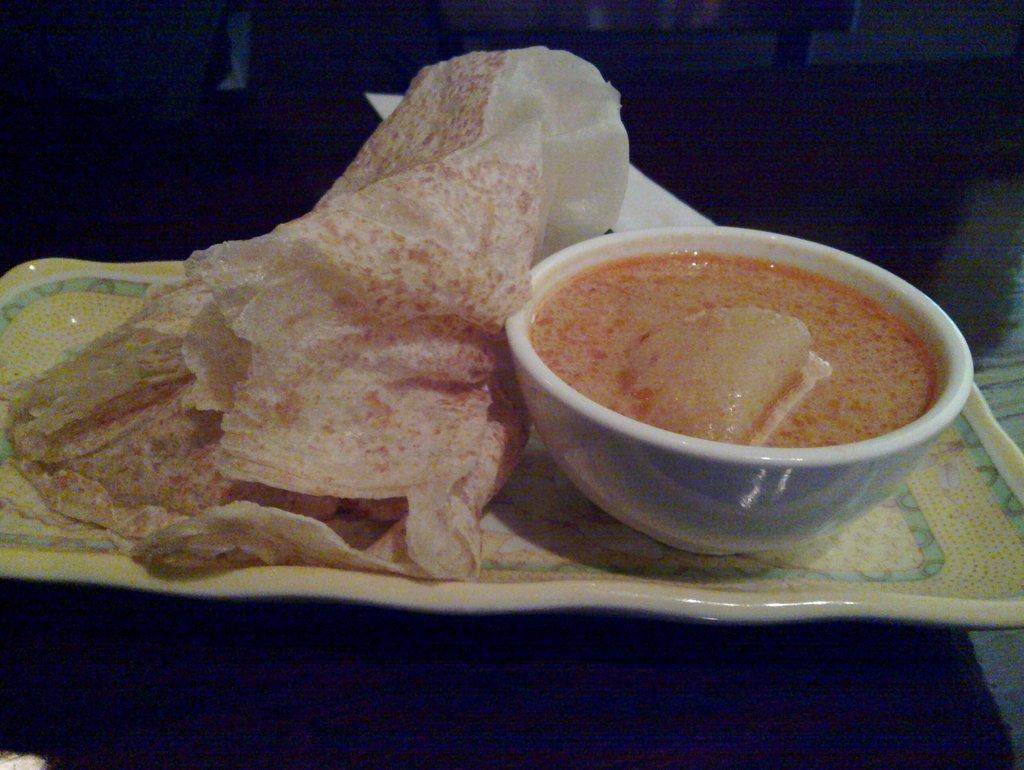What is on the plate that is visible in the image? There is a plate with food in the image. What else is present in the image besides the plate? There is a bowl with food in the image. Where are the plate and bowl located in the image? Both the plate and bowl are placed on a surface. What can be observed about the background of the image? The background of the image is dark. What type of range can be seen in the image? There is no range present in the image. What details about the food can be observed in the image? The provided facts do not give specific details about the food, so we cannot answer this question definitively. 